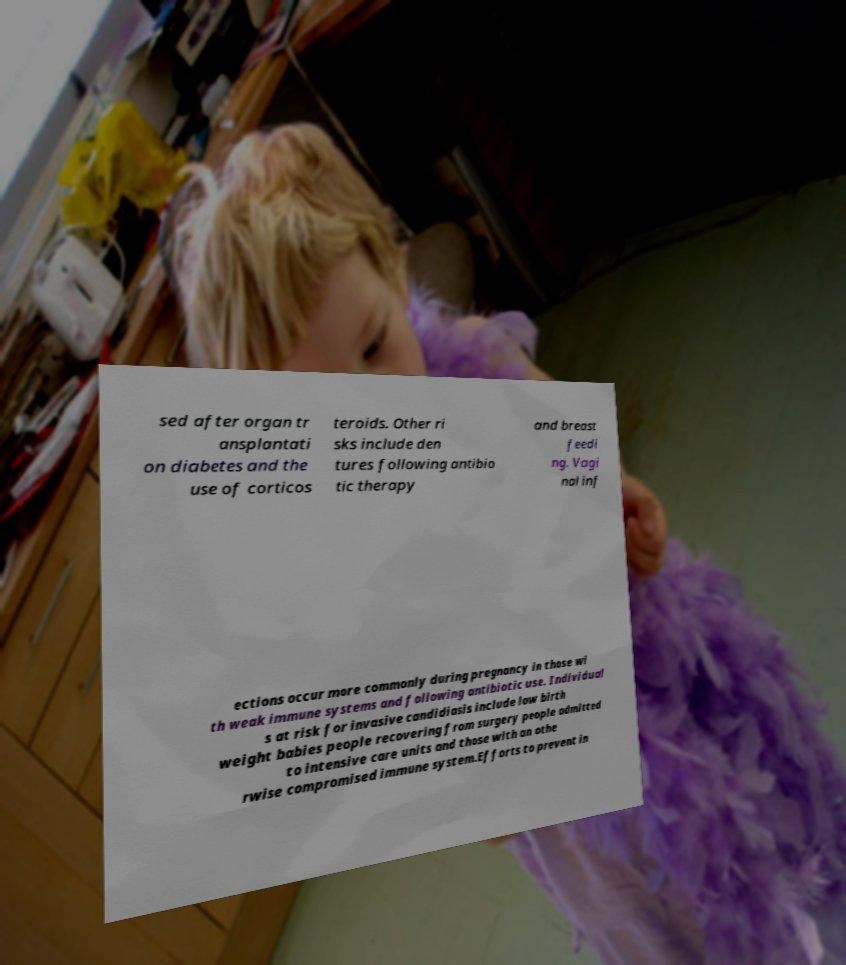What messages or text are displayed in this image? I need them in a readable, typed format. sed after organ tr ansplantati on diabetes and the use of corticos teroids. Other ri sks include den tures following antibio tic therapy and breast feedi ng. Vagi nal inf ections occur more commonly during pregnancy in those wi th weak immune systems and following antibiotic use. Individual s at risk for invasive candidiasis include low birth weight babies people recovering from surgery people admitted to intensive care units and those with an othe rwise compromised immune system.Efforts to prevent in 